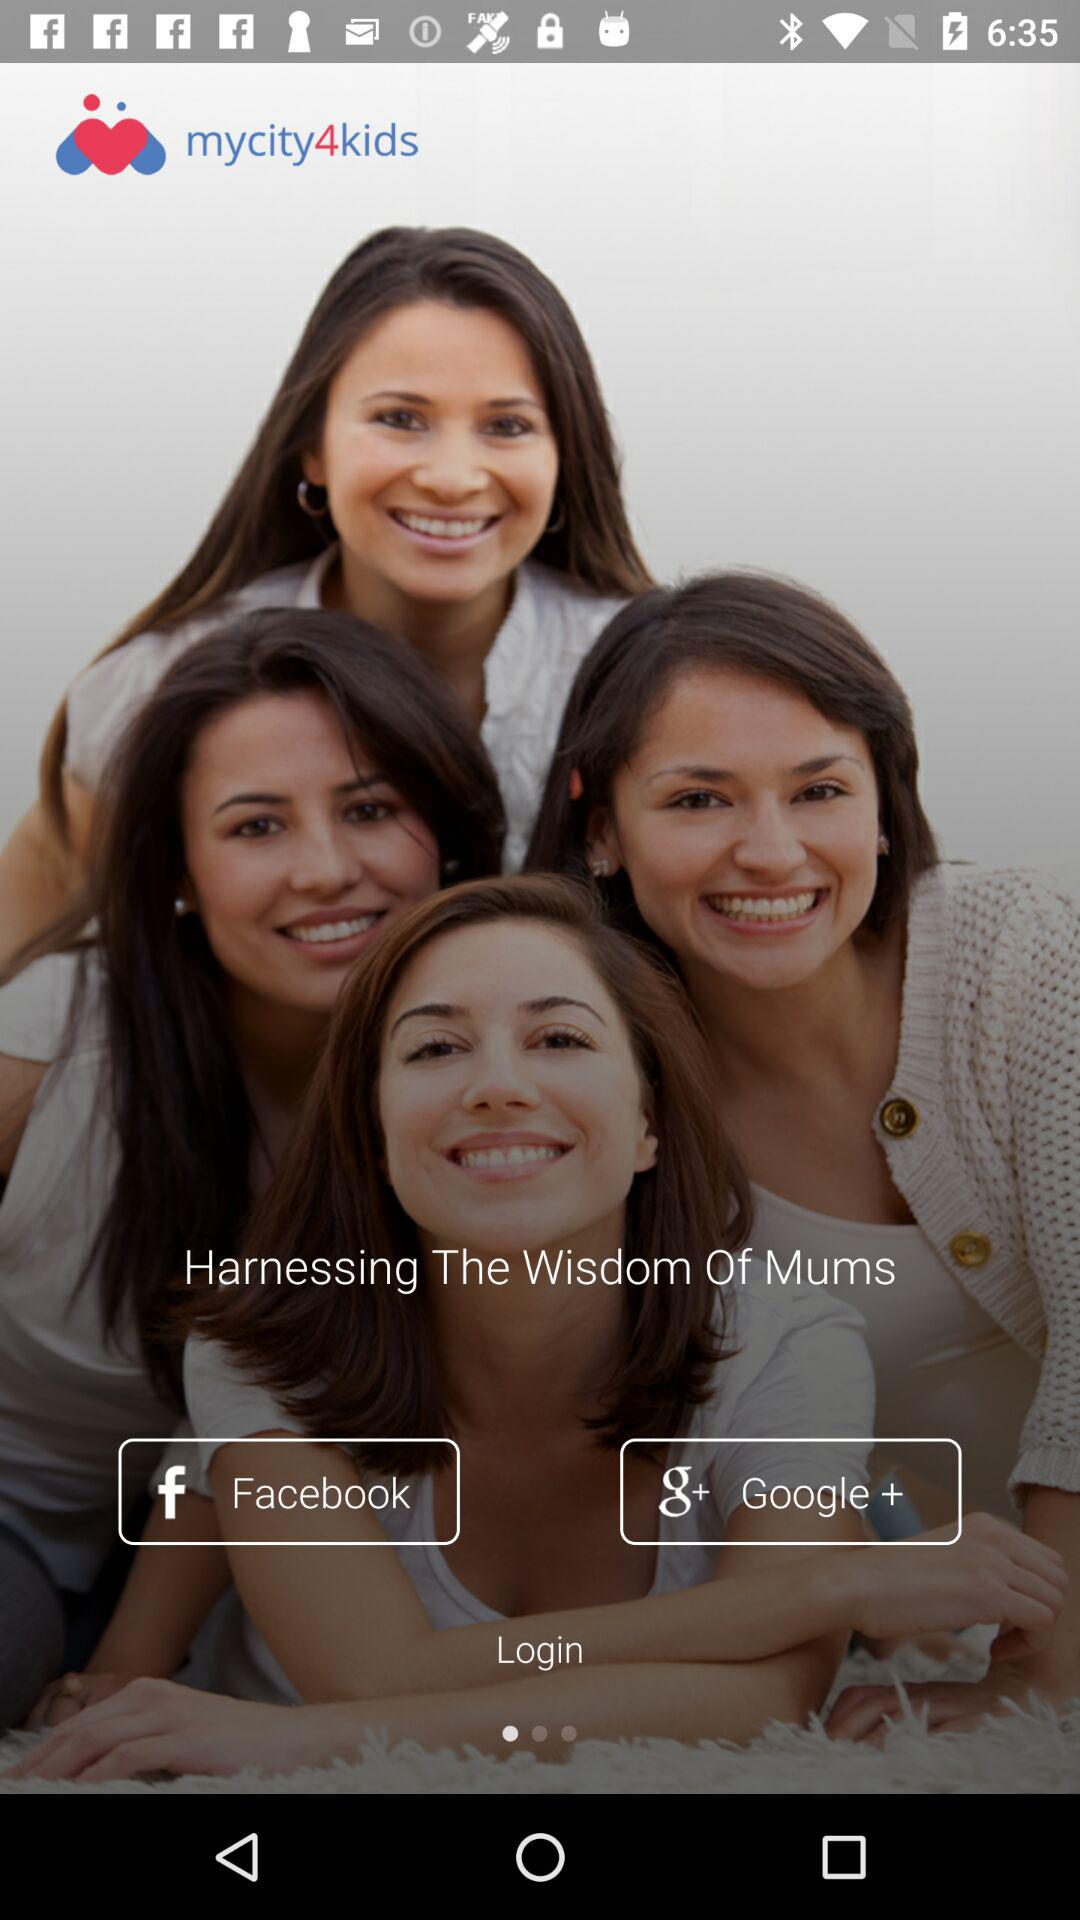What is the name of the application? The name of the application is "mycity4kids". 